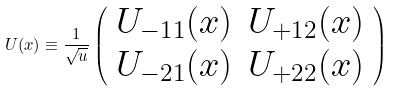Convert formula to latex. <formula><loc_0><loc_0><loc_500><loc_500>U ( x ) \equiv \frac { 1 } { \sqrt { u } } \left ( \begin{array} { c c } U _ { - 1 1 } ( x ) & U _ { + 1 2 } ( x ) \\ U _ { - 2 1 } ( x ) & U _ { + 2 2 } ( x ) \end{array} \right )</formula> 